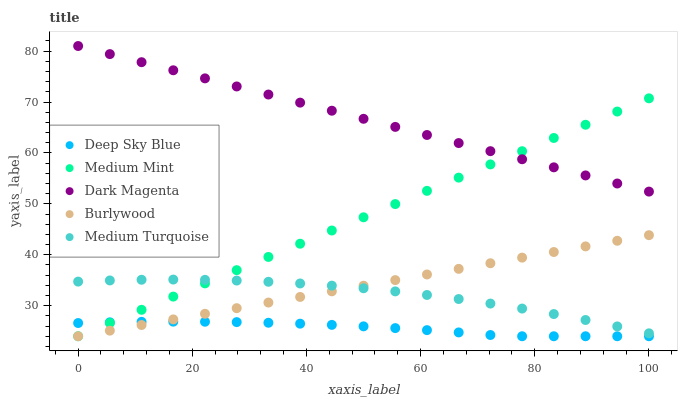Does Deep Sky Blue have the minimum area under the curve?
Answer yes or no. Yes. Does Dark Magenta have the maximum area under the curve?
Answer yes or no. Yes. Does Burlywood have the minimum area under the curve?
Answer yes or no. No. Does Burlywood have the maximum area under the curve?
Answer yes or no. No. Is Burlywood the smoothest?
Answer yes or no. Yes. Is Medium Turquoise the roughest?
Answer yes or no. Yes. Is Medium Turquoise the smoothest?
Answer yes or no. No. Is Burlywood the roughest?
Answer yes or no. No. Does Medium Mint have the lowest value?
Answer yes or no. Yes. Does Medium Turquoise have the lowest value?
Answer yes or no. No. Does Dark Magenta have the highest value?
Answer yes or no. Yes. Does Burlywood have the highest value?
Answer yes or no. No. Is Deep Sky Blue less than Dark Magenta?
Answer yes or no. Yes. Is Medium Turquoise greater than Deep Sky Blue?
Answer yes or no. Yes. Does Medium Mint intersect Burlywood?
Answer yes or no. Yes. Is Medium Mint less than Burlywood?
Answer yes or no. No. Is Medium Mint greater than Burlywood?
Answer yes or no. No. Does Deep Sky Blue intersect Dark Magenta?
Answer yes or no. No. 